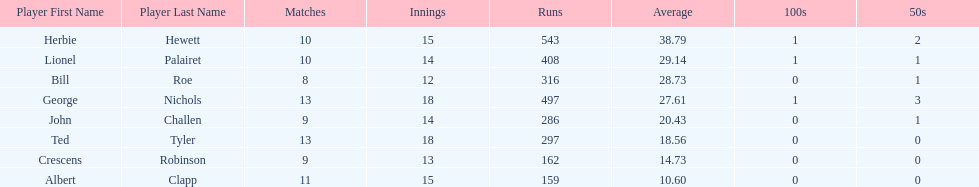Name a player whose average was above 25. Herbie Hewett. 